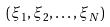Convert formula to latex. <formula><loc_0><loc_0><loc_500><loc_500>( \xi _ { 1 } , \xi _ { 2 } , \dots , \xi _ { N } )</formula> 